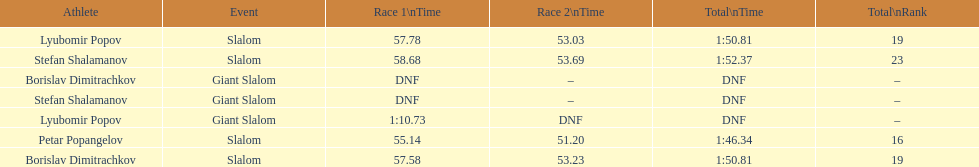Who was last in the slalom overall? Stefan Shalamanov. 